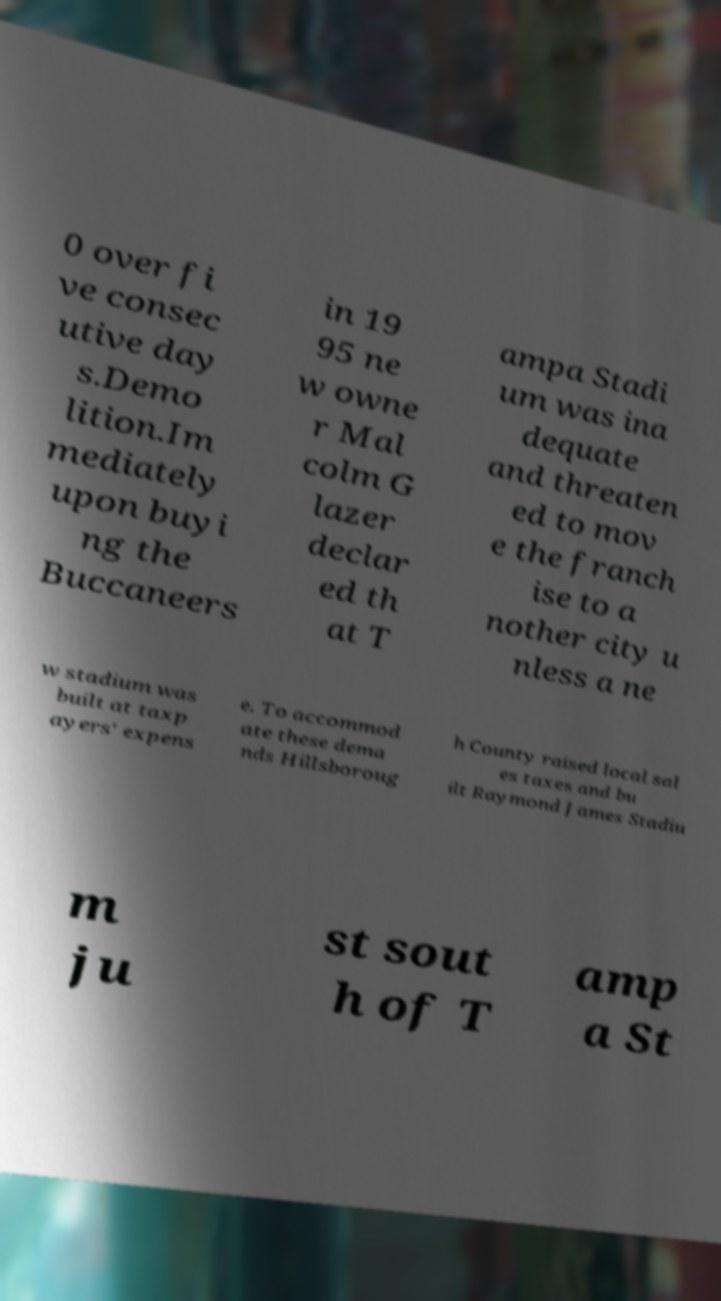There's text embedded in this image that I need extracted. Can you transcribe it verbatim? 0 over fi ve consec utive day s.Demo lition.Im mediately upon buyi ng the Buccaneers in 19 95 ne w owne r Mal colm G lazer declar ed th at T ampa Stadi um was ina dequate and threaten ed to mov e the franch ise to a nother city u nless a ne w stadium was built at taxp ayers' expens e. To accommod ate these dema nds Hillsboroug h County raised local sal es taxes and bu ilt Raymond James Stadiu m ju st sout h of T amp a St 